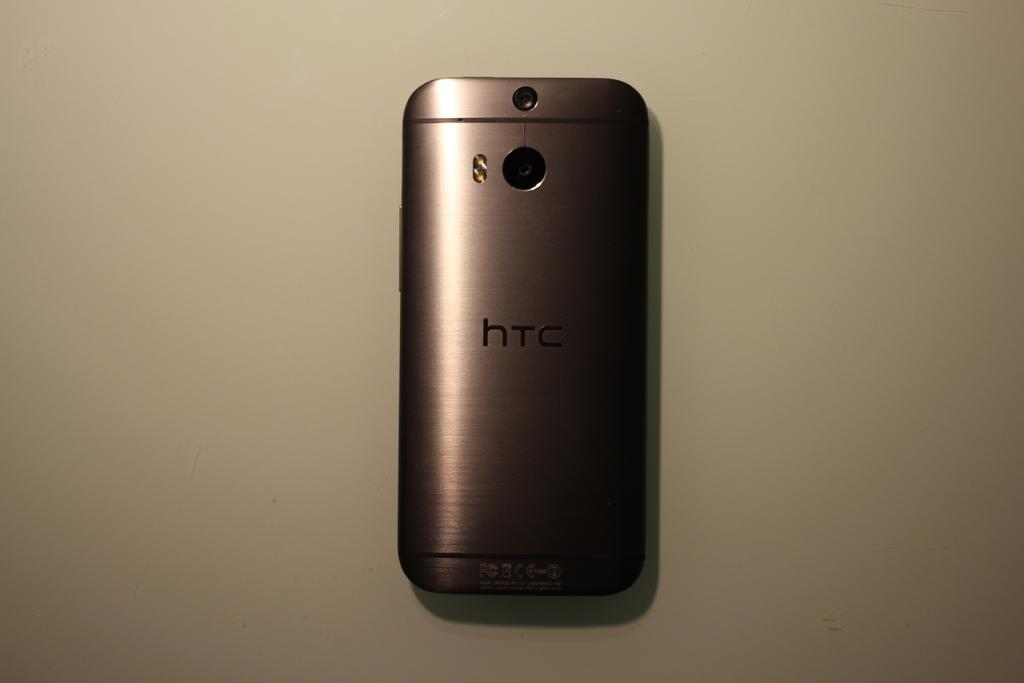<image>
Offer a succinct explanation of the picture presented. A black smarthpone with HTC written on the back lays face down. 